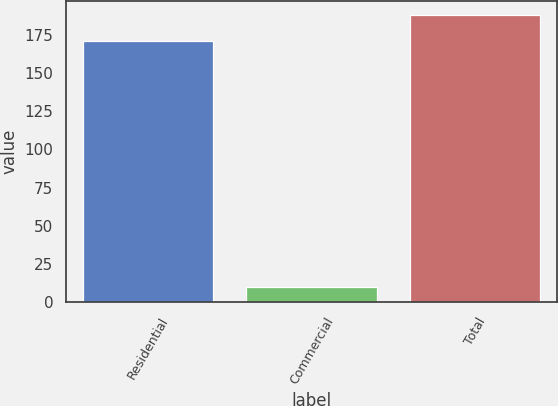Convert chart. <chart><loc_0><loc_0><loc_500><loc_500><bar_chart><fcel>Residential<fcel>Commercial<fcel>Total<nl><fcel>171<fcel>10<fcel>188.1<nl></chart> 